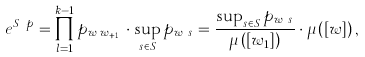Convert formula to latex. <formula><loc_0><loc_0><loc_500><loc_500>e ^ { S _ { w } p } = \prod _ { l = 1 } ^ { k - 1 } p _ { w _ { l } w _ { l + 1 } } \cdot \sup _ { s \in S } p _ { w _ { k } s } = \frac { \sup _ { s \in S } p _ { w _ { k } s } } { \mu \left ( \left [ w _ { 1 } \right ] \right ) } \cdot \mu \left ( \left [ w \right ] \right ) ,</formula> 